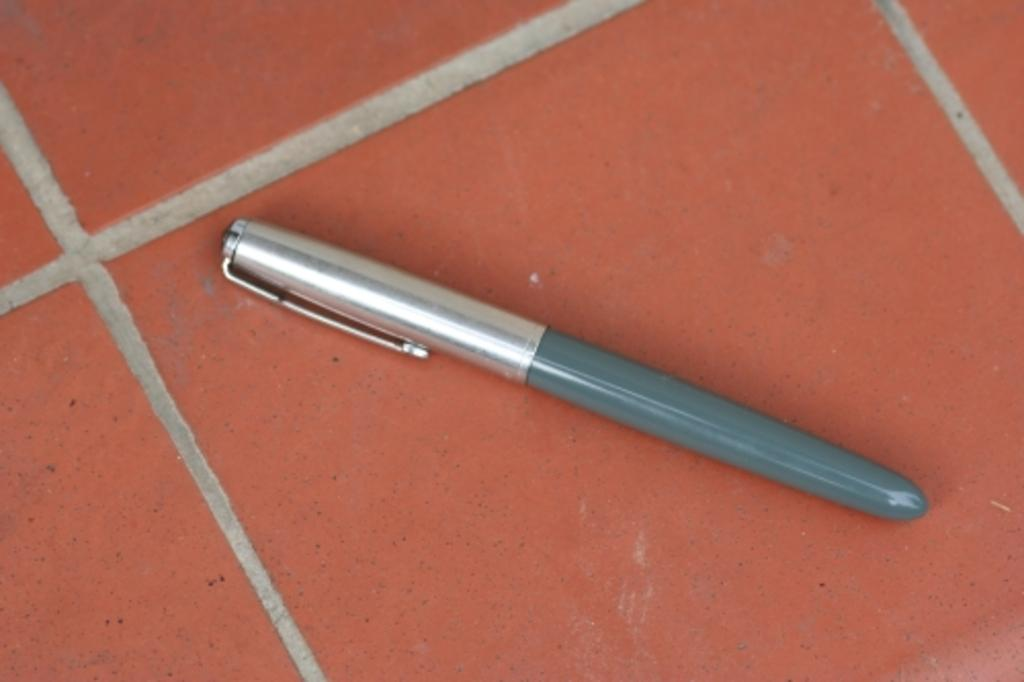What object is present on the floor in the image? There is a pen in the image. What color is the floor where the pen is placed? The floor is red in color. Is there a volcano erupting on the page next to the pen in the image? There is no page or volcano present in the image; it only features a pen on a red floor. 